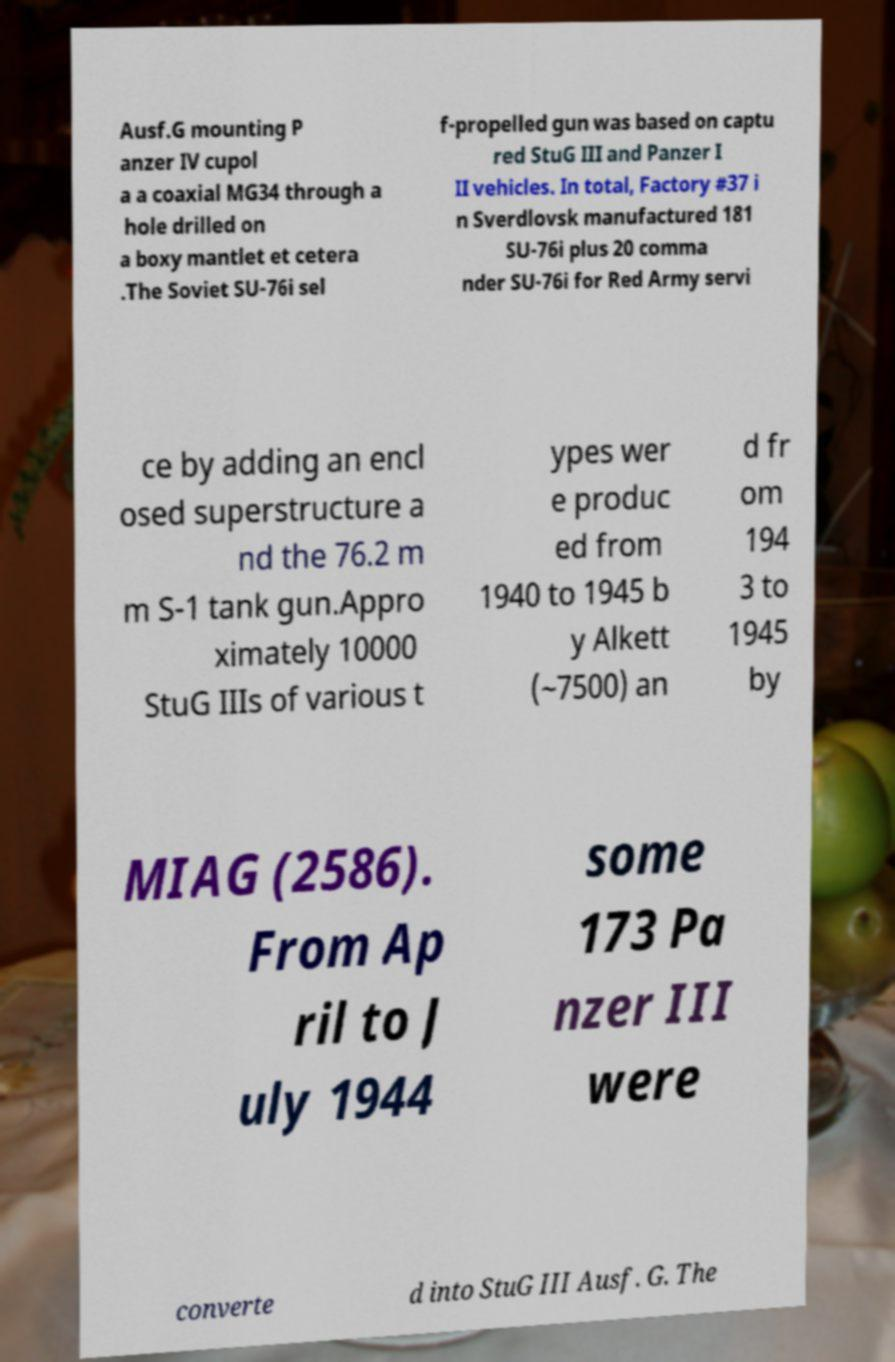What messages or text are displayed in this image? I need them in a readable, typed format. Ausf.G mounting P anzer IV cupol a a coaxial MG34 through a hole drilled on a boxy mantlet et cetera .The Soviet SU-76i sel f-propelled gun was based on captu red StuG III and Panzer I II vehicles. In total, Factory #37 i n Sverdlovsk manufactured 181 SU-76i plus 20 comma nder SU-76i for Red Army servi ce by adding an encl osed superstructure a nd the 76.2 m m S-1 tank gun.Appro ximately 10000 StuG IIIs of various t ypes wer e produc ed from 1940 to 1945 b y Alkett (~7500) an d fr om 194 3 to 1945 by MIAG (2586). From Ap ril to J uly 1944 some 173 Pa nzer III were converte d into StuG III Ausf. G. The 